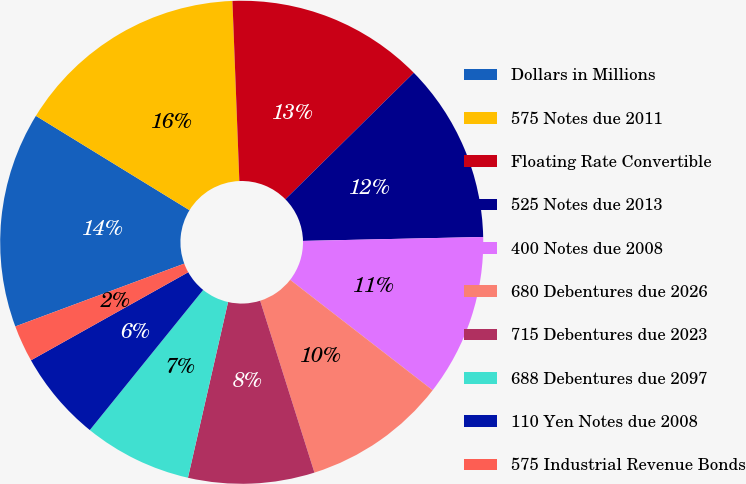Convert chart to OTSL. <chart><loc_0><loc_0><loc_500><loc_500><pie_chart><fcel>Dollars in Millions<fcel>575 Notes due 2011<fcel>Floating Rate Convertible<fcel>525 Notes due 2013<fcel>400 Notes due 2008<fcel>680 Debentures due 2026<fcel>715 Debentures due 2023<fcel>688 Debentures due 2097<fcel>110 Yen Notes due 2008<fcel>575 Industrial Revenue Bonds<nl><fcel>14.43%<fcel>15.62%<fcel>13.23%<fcel>12.03%<fcel>10.84%<fcel>9.64%<fcel>8.44%<fcel>7.25%<fcel>6.05%<fcel>2.46%<nl></chart> 